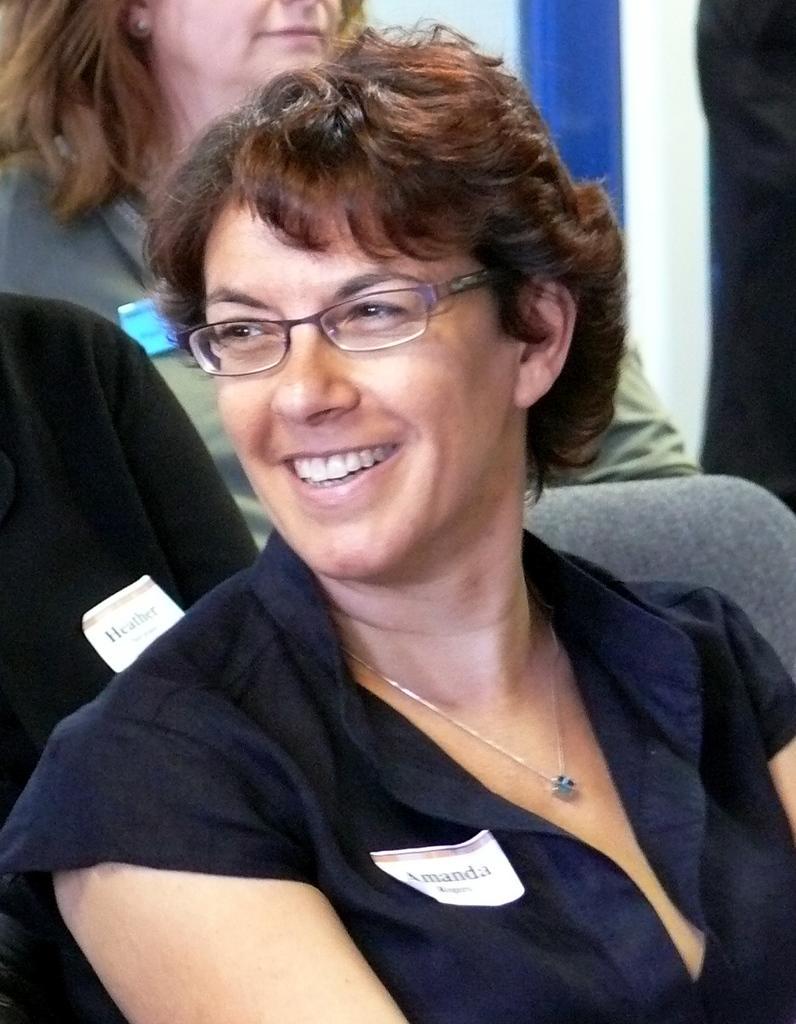Describe this image in one or two sentences. In this picture we can see a woman wore spectacle and sitting on a chair and smiling and in the background we can see some persons. 